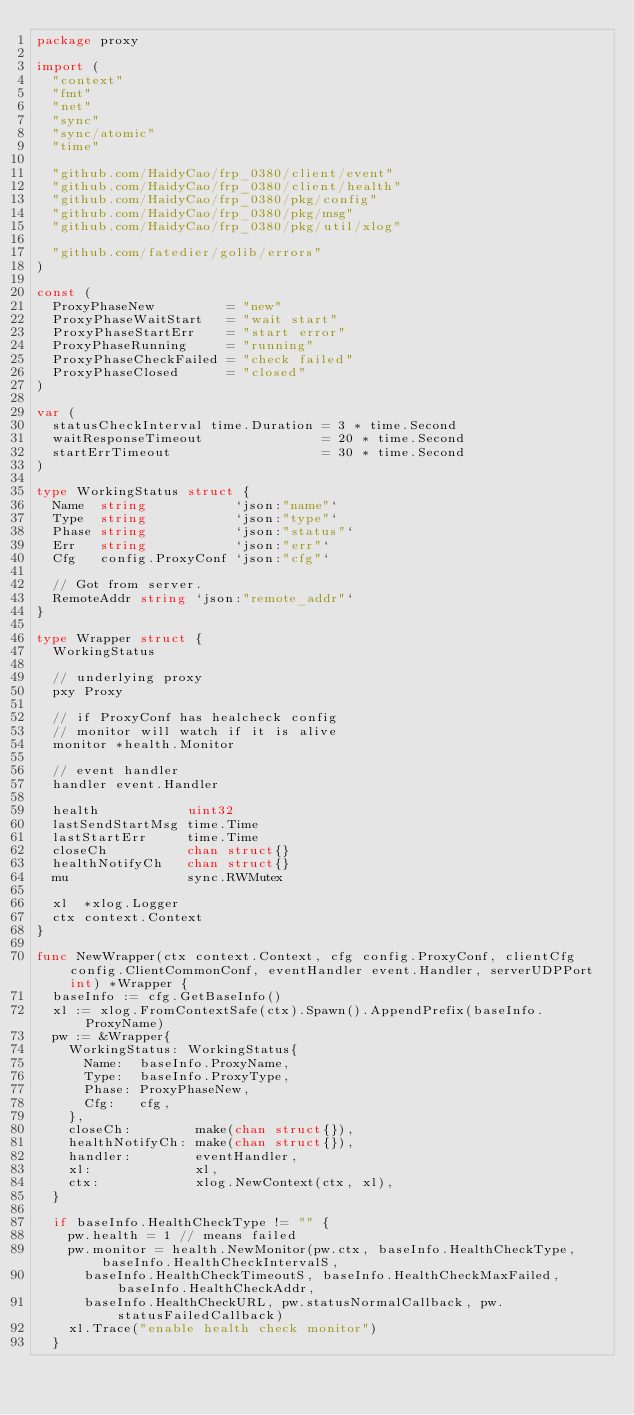<code> <loc_0><loc_0><loc_500><loc_500><_Go_>package proxy

import (
	"context"
	"fmt"
	"net"
	"sync"
	"sync/atomic"
	"time"

	"github.com/HaidyCao/frp_0380/client/event"
	"github.com/HaidyCao/frp_0380/client/health"
	"github.com/HaidyCao/frp_0380/pkg/config"
	"github.com/HaidyCao/frp_0380/pkg/msg"
	"github.com/HaidyCao/frp_0380/pkg/util/xlog"

	"github.com/fatedier/golib/errors"
)

const (
	ProxyPhaseNew         = "new"
	ProxyPhaseWaitStart   = "wait start"
	ProxyPhaseStartErr    = "start error"
	ProxyPhaseRunning     = "running"
	ProxyPhaseCheckFailed = "check failed"
	ProxyPhaseClosed      = "closed"
)

var (
	statusCheckInterval time.Duration = 3 * time.Second
	waitResponseTimeout               = 20 * time.Second
	startErrTimeout                   = 30 * time.Second
)

type WorkingStatus struct {
	Name  string           `json:"name"`
	Type  string           `json:"type"`
	Phase string           `json:"status"`
	Err   string           `json:"err"`
	Cfg   config.ProxyConf `json:"cfg"`

	// Got from server.
	RemoteAddr string `json:"remote_addr"`
}

type Wrapper struct {
	WorkingStatus

	// underlying proxy
	pxy Proxy

	// if ProxyConf has healcheck config
	// monitor will watch if it is alive
	monitor *health.Monitor

	// event handler
	handler event.Handler

	health           uint32
	lastSendStartMsg time.Time
	lastStartErr     time.Time
	closeCh          chan struct{}
	healthNotifyCh   chan struct{}
	mu               sync.RWMutex

	xl  *xlog.Logger
	ctx context.Context
}

func NewWrapper(ctx context.Context, cfg config.ProxyConf, clientCfg config.ClientCommonConf, eventHandler event.Handler, serverUDPPort int) *Wrapper {
	baseInfo := cfg.GetBaseInfo()
	xl := xlog.FromContextSafe(ctx).Spawn().AppendPrefix(baseInfo.ProxyName)
	pw := &Wrapper{
		WorkingStatus: WorkingStatus{
			Name:  baseInfo.ProxyName,
			Type:  baseInfo.ProxyType,
			Phase: ProxyPhaseNew,
			Cfg:   cfg,
		},
		closeCh:        make(chan struct{}),
		healthNotifyCh: make(chan struct{}),
		handler:        eventHandler,
		xl:             xl,
		ctx:            xlog.NewContext(ctx, xl),
	}

	if baseInfo.HealthCheckType != "" {
		pw.health = 1 // means failed
		pw.monitor = health.NewMonitor(pw.ctx, baseInfo.HealthCheckType, baseInfo.HealthCheckIntervalS,
			baseInfo.HealthCheckTimeoutS, baseInfo.HealthCheckMaxFailed, baseInfo.HealthCheckAddr,
			baseInfo.HealthCheckURL, pw.statusNormalCallback, pw.statusFailedCallback)
		xl.Trace("enable health check monitor")
	}
</code> 